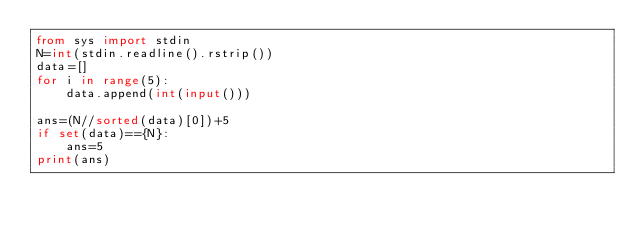<code> <loc_0><loc_0><loc_500><loc_500><_Python_>from sys import stdin
N=int(stdin.readline().rstrip())
data=[]
for i in range(5):
    data.append(int(input()))
    
ans=(N//sorted(data)[0])+5
if set(data)=={N}:
    ans=5
print(ans)</code> 